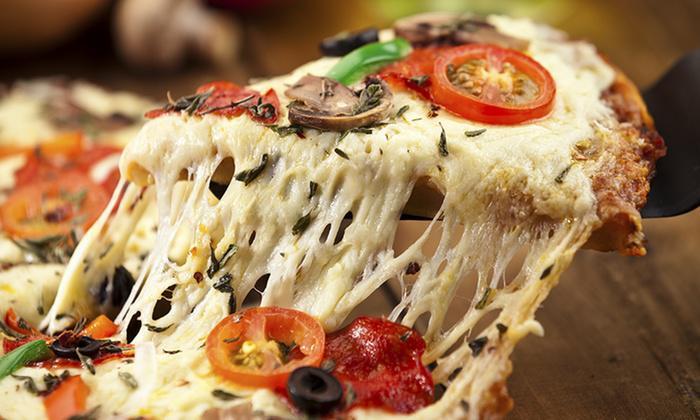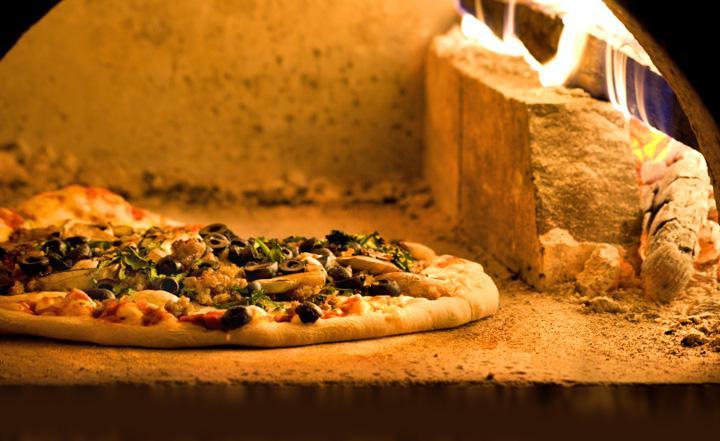The first image is the image on the left, the second image is the image on the right. Assess this claim about the two images: "In the left image a slice is being lifted off the pizza.". Correct or not? Answer yes or no. Yes. The first image is the image on the left, the second image is the image on the right. Assess this claim about the two images: "Four pizzas are visible.". Correct or not? Answer yes or no. No. 